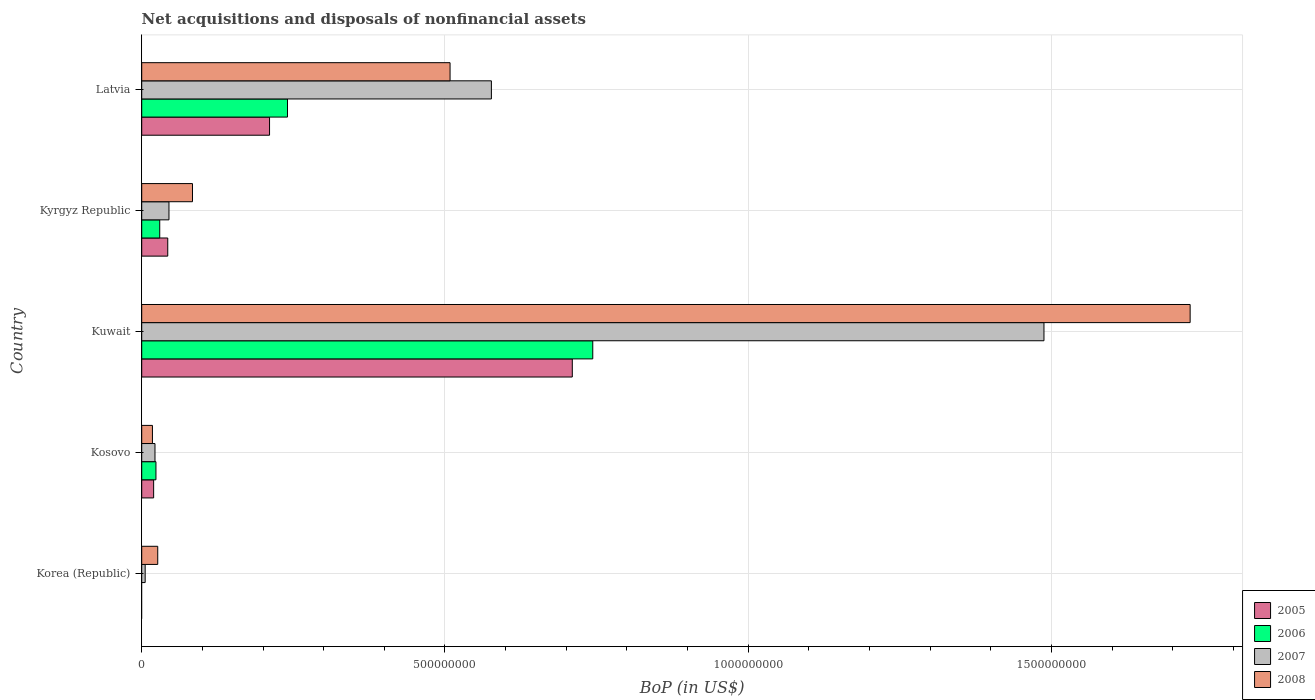How many groups of bars are there?
Ensure brevity in your answer.  5. Are the number of bars on each tick of the Y-axis equal?
Your answer should be very brief. No. How many bars are there on the 1st tick from the top?
Your answer should be compact. 4. What is the Balance of Payments in 2006 in Kyrgyz Republic?
Your answer should be very brief. 2.97e+07. Across all countries, what is the maximum Balance of Payments in 2007?
Offer a very short reply. 1.49e+09. Across all countries, what is the minimum Balance of Payments in 2006?
Provide a succinct answer. 0. In which country was the Balance of Payments in 2007 maximum?
Give a very brief answer. Kuwait. What is the total Balance of Payments in 2008 in the graph?
Offer a terse response. 2.36e+09. What is the difference between the Balance of Payments in 2006 in Kosovo and that in Kyrgyz Republic?
Provide a succinct answer. -6.25e+06. What is the difference between the Balance of Payments in 2006 in Kosovo and the Balance of Payments in 2007 in Korea (Republic)?
Provide a succinct answer. 1.78e+07. What is the average Balance of Payments in 2005 per country?
Offer a very short reply. 1.97e+08. What is the difference between the Balance of Payments in 2006 and Balance of Payments in 2008 in Kyrgyz Republic?
Offer a very short reply. -5.40e+07. What is the ratio of the Balance of Payments in 2006 in Kosovo to that in Kyrgyz Republic?
Make the answer very short. 0.79. Is the Balance of Payments in 2007 in Kuwait less than that in Latvia?
Give a very brief answer. No. What is the difference between the highest and the second highest Balance of Payments in 2006?
Offer a terse response. 5.03e+08. What is the difference between the highest and the lowest Balance of Payments in 2007?
Provide a short and direct response. 1.48e+09. Is the sum of the Balance of Payments in 2007 in Kosovo and Kuwait greater than the maximum Balance of Payments in 2008 across all countries?
Ensure brevity in your answer.  No. Is it the case that in every country, the sum of the Balance of Payments in 2006 and Balance of Payments in 2005 is greater than the sum of Balance of Payments in 2008 and Balance of Payments in 2007?
Give a very brief answer. No. How many countries are there in the graph?
Your answer should be compact. 5. What is the difference between two consecutive major ticks on the X-axis?
Provide a short and direct response. 5.00e+08. Does the graph contain any zero values?
Provide a succinct answer. Yes. How many legend labels are there?
Offer a very short reply. 4. How are the legend labels stacked?
Your answer should be compact. Vertical. What is the title of the graph?
Keep it short and to the point. Net acquisitions and disposals of nonfinancial assets. What is the label or title of the X-axis?
Your answer should be very brief. BoP (in US$). What is the BoP (in US$) in 2007 in Korea (Republic)?
Keep it short and to the point. 5.70e+06. What is the BoP (in US$) in 2008 in Korea (Republic)?
Your answer should be very brief. 2.64e+07. What is the BoP (in US$) of 2005 in Kosovo?
Offer a terse response. 1.96e+07. What is the BoP (in US$) of 2006 in Kosovo?
Make the answer very short. 2.35e+07. What is the BoP (in US$) in 2007 in Kosovo?
Your response must be concise. 2.19e+07. What is the BoP (in US$) in 2008 in Kosovo?
Your response must be concise. 1.77e+07. What is the BoP (in US$) in 2005 in Kuwait?
Provide a short and direct response. 7.10e+08. What is the BoP (in US$) in 2006 in Kuwait?
Your response must be concise. 7.44e+08. What is the BoP (in US$) in 2007 in Kuwait?
Provide a short and direct response. 1.49e+09. What is the BoP (in US$) in 2008 in Kuwait?
Your answer should be compact. 1.73e+09. What is the BoP (in US$) of 2005 in Kyrgyz Republic?
Give a very brief answer. 4.29e+07. What is the BoP (in US$) of 2006 in Kyrgyz Republic?
Keep it short and to the point. 2.97e+07. What is the BoP (in US$) of 2007 in Kyrgyz Republic?
Provide a succinct answer. 4.49e+07. What is the BoP (in US$) in 2008 in Kyrgyz Republic?
Ensure brevity in your answer.  8.37e+07. What is the BoP (in US$) in 2005 in Latvia?
Your response must be concise. 2.11e+08. What is the BoP (in US$) in 2006 in Latvia?
Your response must be concise. 2.40e+08. What is the BoP (in US$) in 2007 in Latvia?
Make the answer very short. 5.77e+08. What is the BoP (in US$) in 2008 in Latvia?
Make the answer very short. 5.08e+08. Across all countries, what is the maximum BoP (in US$) in 2005?
Your answer should be compact. 7.10e+08. Across all countries, what is the maximum BoP (in US$) in 2006?
Your response must be concise. 7.44e+08. Across all countries, what is the maximum BoP (in US$) in 2007?
Ensure brevity in your answer.  1.49e+09. Across all countries, what is the maximum BoP (in US$) in 2008?
Your answer should be compact. 1.73e+09. Across all countries, what is the minimum BoP (in US$) in 2005?
Your response must be concise. 0. Across all countries, what is the minimum BoP (in US$) in 2006?
Your answer should be compact. 0. Across all countries, what is the minimum BoP (in US$) of 2007?
Provide a short and direct response. 5.70e+06. Across all countries, what is the minimum BoP (in US$) of 2008?
Provide a succinct answer. 1.77e+07. What is the total BoP (in US$) of 2005 in the graph?
Make the answer very short. 9.83e+08. What is the total BoP (in US$) in 2006 in the graph?
Ensure brevity in your answer.  1.04e+09. What is the total BoP (in US$) of 2007 in the graph?
Offer a very short reply. 2.14e+09. What is the total BoP (in US$) in 2008 in the graph?
Make the answer very short. 2.36e+09. What is the difference between the BoP (in US$) in 2007 in Korea (Republic) and that in Kosovo?
Your answer should be compact. -1.62e+07. What is the difference between the BoP (in US$) in 2008 in Korea (Republic) and that in Kosovo?
Offer a very short reply. 8.73e+06. What is the difference between the BoP (in US$) in 2007 in Korea (Republic) and that in Kuwait?
Make the answer very short. -1.48e+09. What is the difference between the BoP (in US$) in 2008 in Korea (Republic) and that in Kuwait?
Provide a short and direct response. -1.70e+09. What is the difference between the BoP (in US$) in 2007 in Korea (Republic) and that in Kyrgyz Republic?
Make the answer very short. -3.92e+07. What is the difference between the BoP (in US$) in 2008 in Korea (Republic) and that in Kyrgyz Republic?
Ensure brevity in your answer.  -5.73e+07. What is the difference between the BoP (in US$) of 2007 in Korea (Republic) and that in Latvia?
Provide a short and direct response. -5.71e+08. What is the difference between the BoP (in US$) of 2008 in Korea (Republic) and that in Latvia?
Offer a very short reply. -4.82e+08. What is the difference between the BoP (in US$) of 2005 in Kosovo and that in Kuwait?
Provide a short and direct response. -6.90e+08. What is the difference between the BoP (in US$) in 2006 in Kosovo and that in Kuwait?
Offer a terse response. -7.20e+08. What is the difference between the BoP (in US$) in 2007 in Kosovo and that in Kuwait?
Provide a succinct answer. -1.47e+09. What is the difference between the BoP (in US$) in 2008 in Kosovo and that in Kuwait?
Keep it short and to the point. -1.71e+09. What is the difference between the BoP (in US$) in 2005 in Kosovo and that in Kyrgyz Republic?
Offer a very short reply. -2.33e+07. What is the difference between the BoP (in US$) in 2006 in Kosovo and that in Kyrgyz Republic?
Ensure brevity in your answer.  -6.25e+06. What is the difference between the BoP (in US$) in 2007 in Kosovo and that in Kyrgyz Republic?
Offer a terse response. -2.31e+07. What is the difference between the BoP (in US$) of 2008 in Kosovo and that in Kyrgyz Republic?
Your answer should be compact. -6.60e+07. What is the difference between the BoP (in US$) of 2005 in Kosovo and that in Latvia?
Ensure brevity in your answer.  -1.91e+08. What is the difference between the BoP (in US$) of 2006 in Kosovo and that in Latvia?
Keep it short and to the point. -2.17e+08. What is the difference between the BoP (in US$) of 2007 in Kosovo and that in Latvia?
Provide a short and direct response. -5.55e+08. What is the difference between the BoP (in US$) of 2008 in Kosovo and that in Latvia?
Make the answer very short. -4.91e+08. What is the difference between the BoP (in US$) in 2005 in Kuwait and that in Kyrgyz Republic?
Keep it short and to the point. 6.67e+08. What is the difference between the BoP (in US$) in 2006 in Kuwait and that in Kyrgyz Republic?
Provide a succinct answer. 7.14e+08. What is the difference between the BoP (in US$) of 2007 in Kuwait and that in Kyrgyz Republic?
Provide a succinct answer. 1.44e+09. What is the difference between the BoP (in US$) of 2008 in Kuwait and that in Kyrgyz Republic?
Provide a short and direct response. 1.64e+09. What is the difference between the BoP (in US$) of 2005 in Kuwait and that in Latvia?
Ensure brevity in your answer.  4.99e+08. What is the difference between the BoP (in US$) of 2006 in Kuwait and that in Latvia?
Offer a very short reply. 5.03e+08. What is the difference between the BoP (in US$) in 2007 in Kuwait and that in Latvia?
Ensure brevity in your answer.  9.11e+08. What is the difference between the BoP (in US$) in 2008 in Kuwait and that in Latvia?
Provide a short and direct response. 1.22e+09. What is the difference between the BoP (in US$) of 2005 in Kyrgyz Republic and that in Latvia?
Keep it short and to the point. -1.68e+08. What is the difference between the BoP (in US$) in 2006 in Kyrgyz Republic and that in Latvia?
Give a very brief answer. -2.11e+08. What is the difference between the BoP (in US$) of 2007 in Kyrgyz Republic and that in Latvia?
Your answer should be compact. -5.32e+08. What is the difference between the BoP (in US$) of 2008 in Kyrgyz Republic and that in Latvia?
Offer a very short reply. -4.25e+08. What is the difference between the BoP (in US$) in 2007 in Korea (Republic) and the BoP (in US$) in 2008 in Kosovo?
Give a very brief answer. -1.20e+07. What is the difference between the BoP (in US$) of 2007 in Korea (Republic) and the BoP (in US$) of 2008 in Kuwait?
Your answer should be very brief. -1.72e+09. What is the difference between the BoP (in US$) of 2007 in Korea (Republic) and the BoP (in US$) of 2008 in Kyrgyz Republic?
Provide a succinct answer. -7.80e+07. What is the difference between the BoP (in US$) in 2007 in Korea (Republic) and the BoP (in US$) in 2008 in Latvia?
Your answer should be very brief. -5.03e+08. What is the difference between the BoP (in US$) of 2005 in Kosovo and the BoP (in US$) of 2006 in Kuwait?
Give a very brief answer. -7.24e+08. What is the difference between the BoP (in US$) of 2005 in Kosovo and the BoP (in US$) of 2007 in Kuwait?
Offer a very short reply. -1.47e+09. What is the difference between the BoP (in US$) of 2005 in Kosovo and the BoP (in US$) of 2008 in Kuwait?
Keep it short and to the point. -1.71e+09. What is the difference between the BoP (in US$) in 2006 in Kosovo and the BoP (in US$) in 2007 in Kuwait?
Offer a terse response. -1.46e+09. What is the difference between the BoP (in US$) of 2006 in Kosovo and the BoP (in US$) of 2008 in Kuwait?
Provide a succinct answer. -1.71e+09. What is the difference between the BoP (in US$) in 2007 in Kosovo and the BoP (in US$) in 2008 in Kuwait?
Ensure brevity in your answer.  -1.71e+09. What is the difference between the BoP (in US$) of 2005 in Kosovo and the BoP (in US$) of 2006 in Kyrgyz Republic?
Provide a short and direct response. -1.01e+07. What is the difference between the BoP (in US$) of 2005 in Kosovo and the BoP (in US$) of 2007 in Kyrgyz Republic?
Offer a very short reply. -2.53e+07. What is the difference between the BoP (in US$) of 2005 in Kosovo and the BoP (in US$) of 2008 in Kyrgyz Republic?
Give a very brief answer. -6.40e+07. What is the difference between the BoP (in US$) in 2006 in Kosovo and the BoP (in US$) in 2007 in Kyrgyz Republic?
Your answer should be very brief. -2.15e+07. What is the difference between the BoP (in US$) of 2006 in Kosovo and the BoP (in US$) of 2008 in Kyrgyz Republic?
Your answer should be compact. -6.02e+07. What is the difference between the BoP (in US$) in 2007 in Kosovo and the BoP (in US$) in 2008 in Kyrgyz Republic?
Your response must be concise. -6.18e+07. What is the difference between the BoP (in US$) of 2005 in Kosovo and the BoP (in US$) of 2006 in Latvia?
Offer a very short reply. -2.21e+08. What is the difference between the BoP (in US$) in 2005 in Kosovo and the BoP (in US$) in 2007 in Latvia?
Provide a succinct answer. -5.57e+08. What is the difference between the BoP (in US$) in 2005 in Kosovo and the BoP (in US$) in 2008 in Latvia?
Provide a short and direct response. -4.89e+08. What is the difference between the BoP (in US$) in 2006 in Kosovo and the BoP (in US$) in 2007 in Latvia?
Your answer should be compact. -5.53e+08. What is the difference between the BoP (in US$) in 2006 in Kosovo and the BoP (in US$) in 2008 in Latvia?
Offer a very short reply. -4.85e+08. What is the difference between the BoP (in US$) in 2007 in Kosovo and the BoP (in US$) in 2008 in Latvia?
Keep it short and to the point. -4.87e+08. What is the difference between the BoP (in US$) in 2005 in Kuwait and the BoP (in US$) in 2006 in Kyrgyz Republic?
Your response must be concise. 6.80e+08. What is the difference between the BoP (in US$) in 2005 in Kuwait and the BoP (in US$) in 2007 in Kyrgyz Republic?
Give a very brief answer. 6.65e+08. What is the difference between the BoP (in US$) in 2005 in Kuwait and the BoP (in US$) in 2008 in Kyrgyz Republic?
Your answer should be compact. 6.26e+08. What is the difference between the BoP (in US$) of 2006 in Kuwait and the BoP (in US$) of 2007 in Kyrgyz Republic?
Your response must be concise. 6.99e+08. What is the difference between the BoP (in US$) of 2006 in Kuwait and the BoP (in US$) of 2008 in Kyrgyz Republic?
Offer a terse response. 6.60e+08. What is the difference between the BoP (in US$) in 2007 in Kuwait and the BoP (in US$) in 2008 in Kyrgyz Republic?
Keep it short and to the point. 1.40e+09. What is the difference between the BoP (in US$) of 2005 in Kuwait and the BoP (in US$) of 2006 in Latvia?
Offer a terse response. 4.70e+08. What is the difference between the BoP (in US$) of 2005 in Kuwait and the BoP (in US$) of 2007 in Latvia?
Keep it short and to the point. 1.33e+08. What is the difference between the BoP (in US$) of 2005 in Kuwait and the BoP (in US$) of 2008 in Latvia?
Offer a very short reply. 2.02e+08. What is the difference between the BoP (in US$) of 2006 in Kuwait and the BoP (in US$) of 2007 in Latvia?
Provide a short and direct response. 1.67e+08. What is the difference between the BoP (in US$) of 2006 in Kuwait and the BoP (in US$) of 2008 in Latvia?
Ensure brevity in your answer.  2.35e+08. What is the difference between the BoP (in US$) of 2007 in Kuwait and the BoP (in US$) of 2008 in Latvia?
Offer a terse response. 9.79e+08. What is the difference between the BoP (in US$) in 2005 in Kyrgyz Republic and the BoP (in US$) in 2006 in Latvia?
Keep it short and to the point. -1.97e+08. What is the difference between the BoP (in US$) in 2005 in Kyrgyz Republic and the BoP (in US$) in 2007 in Latvia?
Offer a very short reply. -5.34e+08. What is the difference between the BoP (in US$) of 2005 in Kyrgyz Republic and the BoP (in US$) of 2008 in Latvia?
Your answer should be very brief. -4.65e+08. What is the difference between the BoP (in US$) in 2006 in Kyrgyz Republic and the BoP (in US$) in 2007 in Latvia?
Your response must be concise. -5.47e+08. What is the difference between the BoP (in US$) of 2006 in Kyrgyz Republic and the BoP (in US$) of 2008 in Latvia?
Ensure brevity in your answer.  -4.79e+08. What is the difference between the BoP (in US$) of 2007 in Kyrgyz Republic and the BoP (in US$) of 2008 in Latvia?
Offer a terse response. -4.63e+08. What is the average BoP (in US$) of 2005 per country?
Keep it short and to the point. 1.97e+08. What is the average BoP (in US$) of 2006 per country?
Give a very brief answer. 2.07e+08. What is the average BoP (in US$) of 2007 per country?
Provide a short and direct response. 4.27e+08. What is the average BoP (in US$) in 2008 per country?
Your response must be concise. 4.73e+08. What is the difference between the BoP (in US$) of 2007 and BoP (in US$) of 2008 in Korea (Republic)?
Ensure brevity in your answer.  -2.07e+07. What is the difference between the BoP (in US$) of 2005 and BoP (in US$) of 2006 in Kosovo?
Keep it short and to the point. -3.81e+06. What is the difference between the BoP (in US$) of 2005 and BoP (in US$) of 2007 in Kosovo?
Your answer should be compact. -2.21e+06. What is the difference between the BoP (in US$) in 2005 and BoP (in US$) in 2008 in Kosovo?
Your response must be concise. 1.97e+06. What is the difference between the BoP (in US$) of 2006 and BoP (in US$) of 2007 in Kosovo?
Ensure brevity in your answer.  1.60e+06. What is the difference between the BoP (in US$) of 2006 and BoP (in US$) of 2008 in Kosovo?
Give a very brief answer. 5.78e+06. What is the difference between the BoP (in US$) of 2007 and BoP (in US$) of 2008 in Kosovo?
Ensure brevity in your answer.  4.18e+06. What is the difference between the BoP (in US$) in 2005 and BoP (in US$) in 2006 in Kuwait?
Offer a terse response. -3.38e+07. What is the difference between the BoP (in US$) in 2005 and BoP (in US$) in 2007 in Kuwait?
Your answer should be compact. -7.78e+08. What is the difference between the BoP (in US$) in 2005 and BoP (in US$) in 2008 in Kuwait?
Offer a terse response. -1.02e+09. What is the difference between the BoP (in US$) of 2006 and BoP (in US$) of 2007 in Kuwait?
Provide a succinct answer. -7.44e+08. What is the difference between the BoP (in US$) in 2006 and BoP (in US$) in 2008 in Kuwait?
Provide a short and direct response. -9.85e+08. What is the difference between the BoP (in US$) in 2007 and BoP (in US$) in 2008 in Kuwait?
Provide a succinct answer. -2.41e+08. What is the difference between the BoP (in US$) of 2005 and BoP (in US$) of 2006 in Kyrgyz Republic?
Your response must be concise. 1.32e+07. What is the difference between the BoP (in US$) of 2005 and BoP (in US$) of 2007 in Kyrgyz Republic?
Make the answer very short. -2.00e+06. What is the difference between the BoP (in US$) in 2005 and BoP (in US$) in 2008 in Kyrgyz Republic?
Make the answer very short. -4.08e+07. What is the difference between the BoP (in US$) in 2006 and BoP (in US$) in 2007 in Kyrgyz Republic?
Keep it short and to the point. -1.52e+07. What is the difference between the BoP (in US$) of 2006 and BoP (in US$) of 2008 in Kyrgyz Republic?
Your answer should be very brief. -5.40e+07. What is the difference between the BoP (in US$) of 2007 and BoP (in US$) of 2008 in Kyrgyz Republic?
Your response must be concise. -3.88e+07. What is the difference between the BoP (in US$) of 2005 and BoP (in US$) of 2006 in Latvia?
Keep it short and to the point. -2.96e+07. What is the difference between the BoP (in US$) in 2005 and BoP (in US$) in 2007 in Latvia?
Offer a very short reply. -3.66e+08. What is the difference between the BoP (in US$) in 2005 and BoP (in US$) in 2008 in Latvia?
Your answer should be very brief. -2.98e+08. What is the difference between the BoP (in US$) of 2006 and BoP (in US$) of 2007 in Latvia?
Your response must be concise. -3.36e+08. What is the difference between the BoP (in US$) in 2006 and BoP (in US$) in 2008 in Latvia?
Keep it short and to the point. -2.68e+08. What is the difference between the BoP (in US$) in 2007 and BoP (in US$) in 2008 in Latvia?
Make the answer very short. 6.82e+07. What is the ratio of the BoP (in US$) of 2007 in Korea (Republic) to that in Kosovo?
Provide a succinct answer. 0.26. What is the ratio of the BoP (in US$) in 2008 in Korea (Republic) to that in Kosovo?
Offer a very short reply. 1.49. What is the ratio of the BoP (in US$) in 2007 in Korea (Republic) to that in Kuwait?
Provide a short and direct response. 0. What is the ratio of the BoP (in US$) of 2008 in Korea (Republic) to that in Kuwait?
Provide a short and direct response. 0.02. What is the ratio of the BoP (in US$) of 2007 in Korea (Republic) to that in Kyrgyz Republic?
Your response must be concise. 0.13. What is the ratio of the BoP (in US$) in 2008 in Korea (Republic) to that in Kyrgyz Republic?
Your response must be concise. 0.32. What is the ratio of the BoP (in US$) of 2007 in Korea (Republic) to that in Latvia?
Your response must be concise. 0.01. What is the ratio of the BoP (in US$) of 2008 in Korea (Republic) to that in Latvia?
Provide a succinct answer. 0.05. What is the ratio of the BoP (in US$) of 2005 in Kosovo to that in Kuwait?
Keep it short and to the point. 0.03. What is the ratio of the BoP (in US$) in 2006 in Kosovo to that in Kuwait?
Provide a short and direct response. 0.03. What is the ratio of the BoP (in US$) of 2007 in Kosovo to that in Kuwait?
Your answer should be compact. 0.01. What is the ratio of the BoP (in US$) of 2008 in Kosovo to that in Kuwait?
Provide a short and direct response. 0.01. What is the ratio of the BoP (in US$) in 2005 in Kosovo to that in Kyrgyz Republic?
Make the answer very short. 0.46. What is the ratio of the BoP (in US$) of 2006 in Kosovo to that in Kyrgyz Republic?
Your answer should be compact. 0.79. What is the ratio of the BoP (in US$) of 2007 in Kosovo to that in Kyrgyz Republic?
Keep it short and to the point. 0.49. What is the ratio of the BoP (in US$) of 2008 in Kosovo to that in Kyrgyz Republic?
Your answer should be very brief. 0.21. What is the ratio of the BoP (in US$) of 2005 in Kosovo to that in Latvia?
Your answer should be compact. 0.09. What is the ratio of the BoP (in US$) of 2006 in Kosovo to that in Latvia?
Your answer should be very brief. 0.1. What is the ratio of the BoP (in US$) of 2007 in Kosovo to that in Latvia?
Give a very brief answer. 0.04. What is the ratio of the BoP (in US$) of 2008 in Kosovo to that in Latvia?
Give a very brief answer. 0.03. What is the ratio of the BoP (in US$) in 2005 in Kuwait to that in Kyrgyz Republic?
Keep it short and to the point. 16.54. What is the ratio of the BoP (in US$) of 2006 in Kuwait to that in Kyrgyz Republic?
Make the answer very short. 25.03. What is the ratio of the BoP (in US$) of 2007 in Kuwait to that in Kyrgyz Republic?
Your answer should be compact. 33.12. What is the ratio of the BoP (in US$) of 2008 in Kuwait to that in Kyrgyz Republic?
Provide a short and direct response. 20.66. What is the ratio of the BoP (in US$) of 2005 in Kuwait to that in Latvia?
Make the answer very short. 3.37. What is the ratio of the BoP (in US$) of 2006 in Kuwait to that in Latvia?
Provide a short and direct response. 3.09. What is the ratio of the BoP (in US$) of 2007 in Kuwait to that in Latvia?
Ensure brevity in your answer.  2.58. What is the ratio of the BoP (in US$) of 2008 in Kuwait to that in Latvia?
Offer a very short reply. 3.4. What is the ratio of the BoP (in US$) in 2005 in Kyrgyz Republic to that in Latvia?
Give a very brief answer. 0.2. What is the ratio of the BoP (in US$) in 2006 in Kyrgyz Republic to that in Latvia?
Your answer should be compact. 0.12. What is the ratio of the BoP (in US$) of 2007 in Kyrgyz Republic to that in Latvia?
Provide a short and direct response. 0.08. What is the ratio of the BoP (in US$) in 2008 in Kyrgyz Republic to that in Latvia?
Provide a succinct answer. 0.16. What is the difference between the highest and the second highest BoP (in US$) of 2005?
Offer a very short reply. 4.99e+08. What is the difference between the highest and the second highest BoP (in US$) in 2006?
Offer a terse response. 5.03e+08. What is the difference between the highest and the second highest BoP (in US$) in 2007?
Offer a terse response. 9.11e+08. What is the difference between the highest and the second highest BoP (in US$) of 2008?
Offer a very short reply. 1.22e+09. What is the difference between the highest and the lowest BoP (in US$) of 2005?
Make the answer very short. 7.10e+08. What is the difference between the highest and the lowest BoP (in US$) in 2006?
Offer a terse response. 7.44e+08. What is the difference between the highest and the lowest BoP (in US$) of 2007?
Make the answer very short. 1.48e+09. What is the difference between the highest and the lowest BoP (in US$) of 2008?
Ensure brevity in your answer.  1.71e+09. 